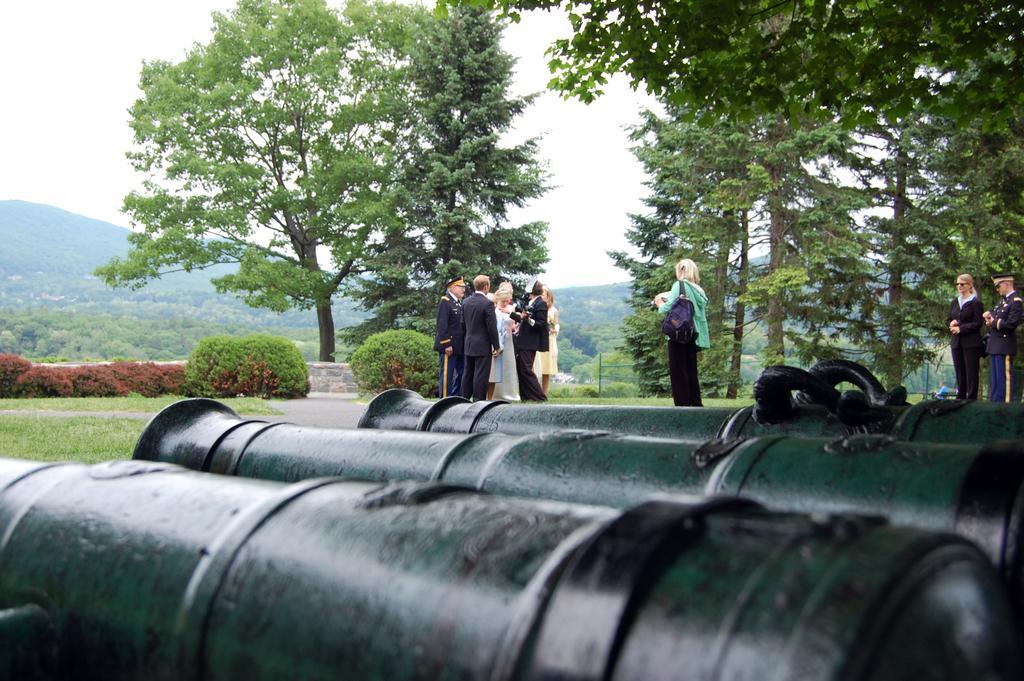How would you summarize this image in a sentence or two? This is an outside view. At the bottom of the image I can see some metal rods on the ground. In the background there are few people standing. It seems like they are discussing something. In the background there are some trees and plants. On the top of the image I can see the sky. 